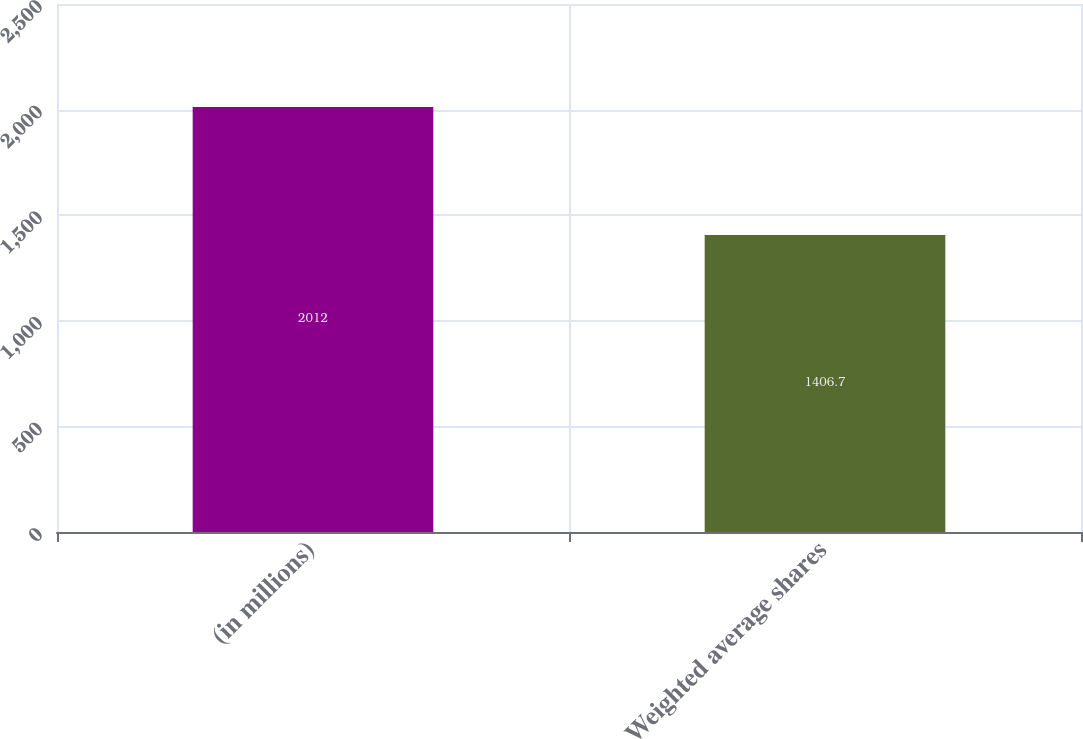<chart> <loc_0><loc_0><loc_500><loc_500><bar_chart><fcel>(in millions)<fcel>Weighted average shares<nl><fcel>2012<fcel>1406.7<nl></chart> 